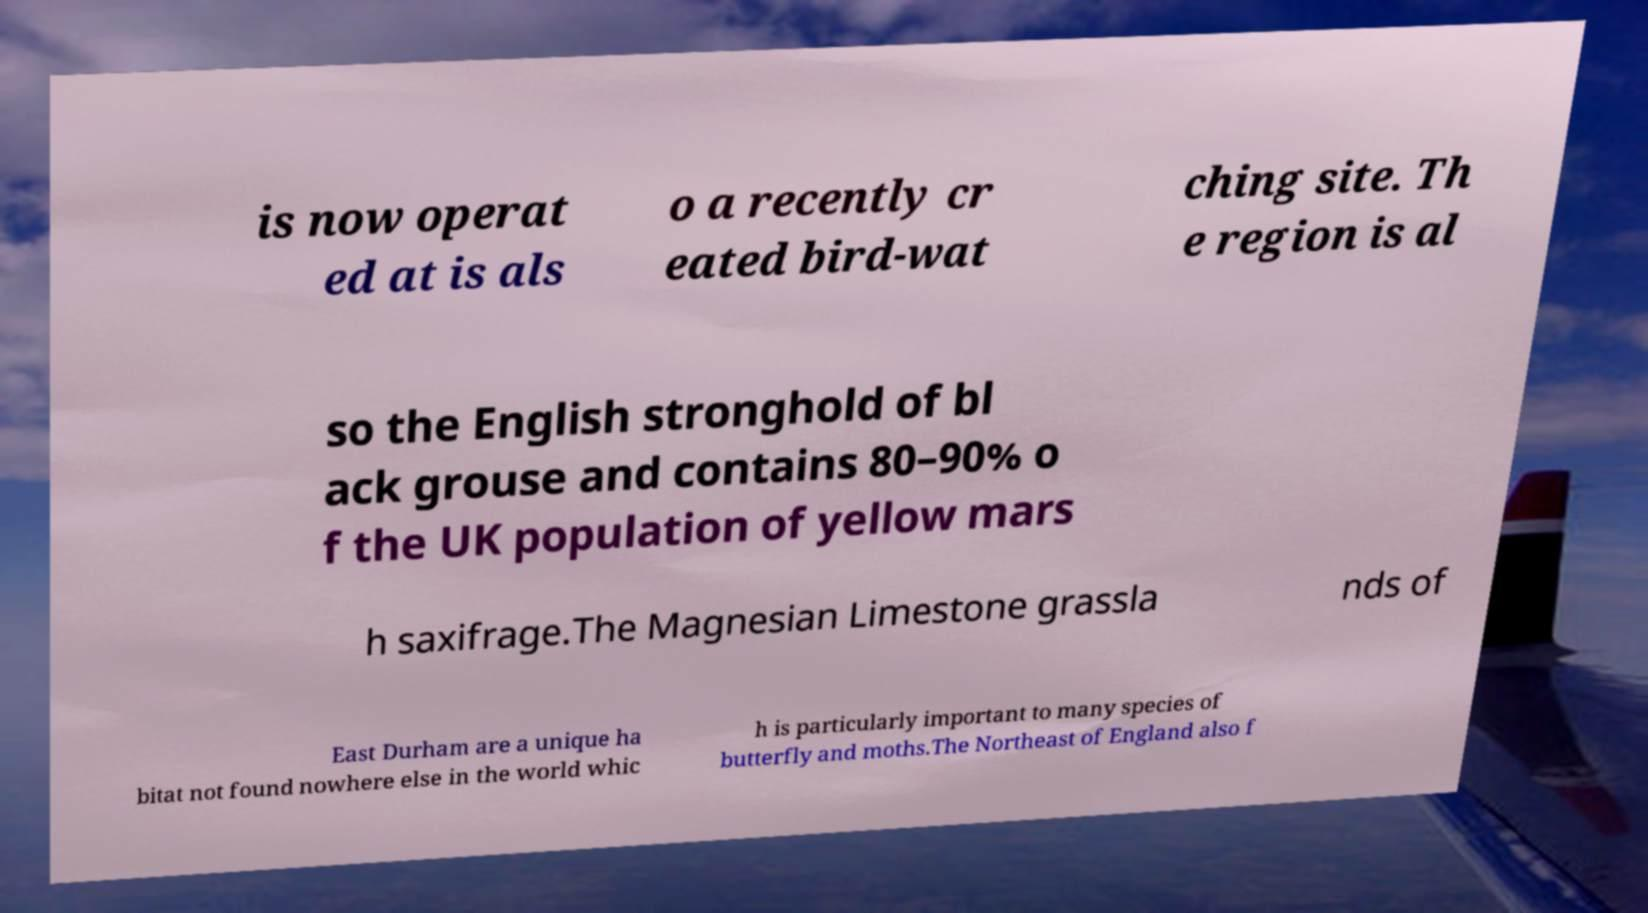Can you accurately transcribe the text from the provided image for me? is now operat ed at is als o a recently cr eated bird-wat ching site. Th e region is al so the English stronghold of bl ack grouse and contains 80–90% o f the UK population of yellow mars h saxifrage.The Magnesian Limestone grassla nds of East Durham are a unique ha bitat not found nowhere else in the world whic h is particularly important to many species of butterfly and moths.The Northeast of England also f 